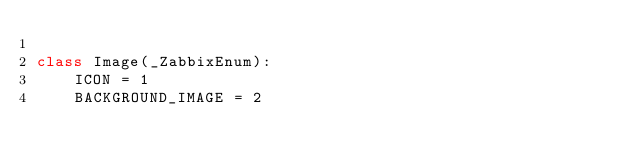Convert code to text. <code><loc_0><loc_0><loc_500><loc_500><_Python_>
class Image(_ZabbixEnum):
    ICON = 1
    BACKGROUND_IMAGE = 2
</code> 